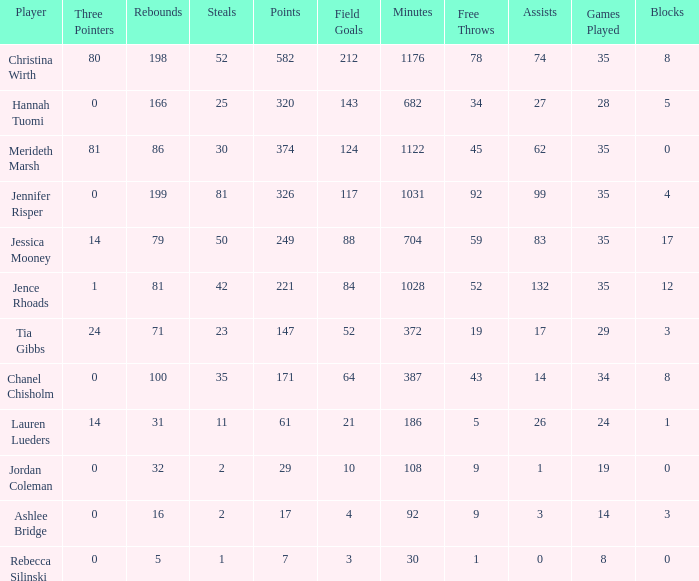What is the lowest number of 3 pointers that occured in games with 52 steals? 80.0. 